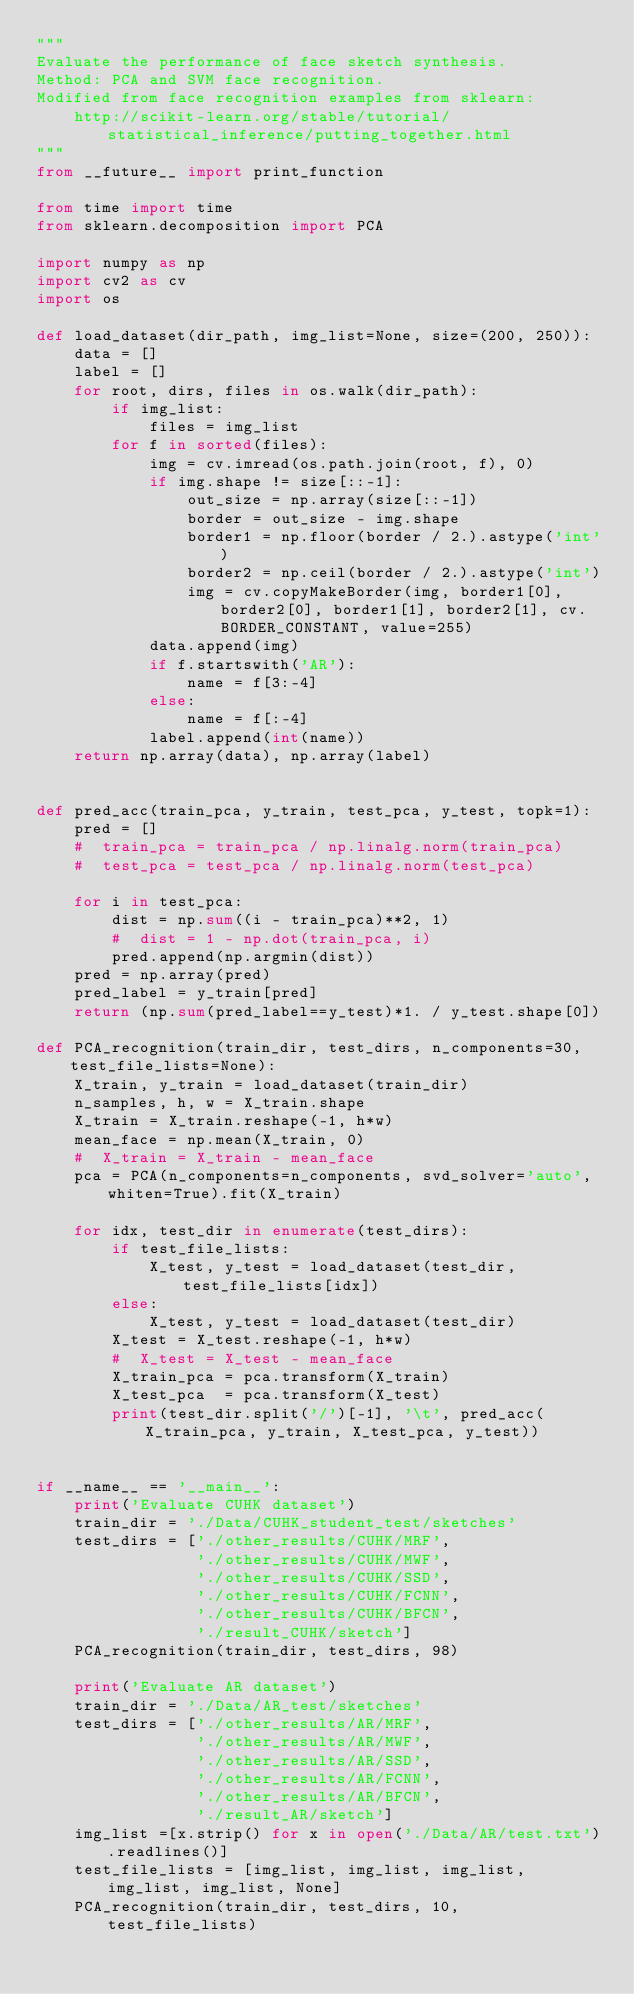Convert code to text. <code><loc_0><loc_0><loc_500><loc_500><_Python_>"""
Evaluate the performance of face sketch synthesis.
Method: PCA and SVM face recognition.
Modified from face recognition examples from sklearn: 
    http://scikit-learn.org/stable/tutorial/statistical_inference/putting_together.html
"""
from __future__ import print_function

from time import time
from sklearn.decomposition import PCA

import numpy as np
import cv2 as cv
import os

def load_dataset(dir_path, img_list=None, size=(200, 250)):
    data = []
    label = []
    for root, dirs, files in os.walk(dir_path):
        if img_list:
            files = img_list
        for f in sorted(files):
            img = cv.imread(os.path.join(root, f), 0)
            if img.shape != size[::-1]:
                out_size = np.array(size[::-1])
                border = out_size - img.shape
                border1 = np.floor(border / 2.).astype('int')
                border2 = np.ceil(border / 2.).astype('int')
                img = cv.copyMakeBorder(img, border1[0], border2[0], border1[1], border2[1], cv.BORDER_CONSTANT, value=255)
            data.append(img)
            if f.startswith('AR'):
                name = f[3:-4]
            else:
                name = f[:-4]
            label.append(int(name))
    return np.array(data), np.array(label)


def pred_acc(train_pca, y_train, test_pca, y_test, topk=1):
    pred = []
    #  train_pca = train_pca / np.linalg.norm(train_pca)
    #  test_pca = test_pca / np.linalg.norm(test_pca)
    
    for i in test_pca:
        dist = np.sum((i - train_pca)**2, 1)
        #  dist = 1 - np.dot(train_pca, i)
        pred.append(np.argmin(dist))
    pred = np.array(pred)
    pred_label = y_train[pred]
    return (np.sum(pred_label==y_test)*1. / y_test.shape[0])

def PCA_recognition(train_dir, test_dirs, n_components=30, test_file_lists=None):
    X_train, y_train = load_dataset(train_dir)
    n_samples, h, w = X_train.shape
    X_train = X_train.reshape(-1, h*w)
    mean_face = np.mean(X_train, 0)
    #  X_train = X_train - mean_face
    pca = PCA(n_components=n_components, svd_solver='auto', whiten=True).fit(X_train)

    for idx, test_dir in enumerate(test_dirs):
        if test_file_lists:
            X_test, y_test = load_dataset(test_dir, test_file_lists[idx])
        else:
            X_test, y_test = load_dataset(test_dir)
        X_test = X_test.reshape(-1, h*w)
        #  X_test = X_test - mean_face 
        X_train_pca = pca.transform(X_train)
        X_test_pca  = pca.transform(X_test)
        print(test_dir.split('/')[-1], '\t', pred_acc(X_train_pca, y_train, X_test_pca, y_test))


if __name__ == '__main__':
    print('Evaluate CUHK dataset')
    train_dir = './Data/CUHK_student_test/sketches'
    test_dirs = ['./other_results/CUHK/MRF',
                 './other_results/CUHK/MWF',
                 './other_results/CUHK/SSD',
                 './other_results/CUHK/FCNN',
                 './other_results/CUHK/BFCN',
                 './result_CUHK/sketch']
    PCA_recognition(train_dir, test_dirs, 98)

    print('Evaluate AR dataset')
    train_dir = './Data/AR_test/sketches'
    test_dirs = ['./other_results/AR/MRF',
                 './other_results/AR/MWF',
                 './other_results/AR/SSD',
                 './other_results/AR/FCNN',
                 './other_results/AR/BFCN',
                 './result_AR/sketch']
    img_list =[x.strip() for x in open('./Data/AR/test.txt').readlines()]
    test_file_lists = [img_list, img_list, img_list, img_list, img_list, None]
    PCA_recognition(train_dir, test_dirs, 10, test_file_lists)



</code> 